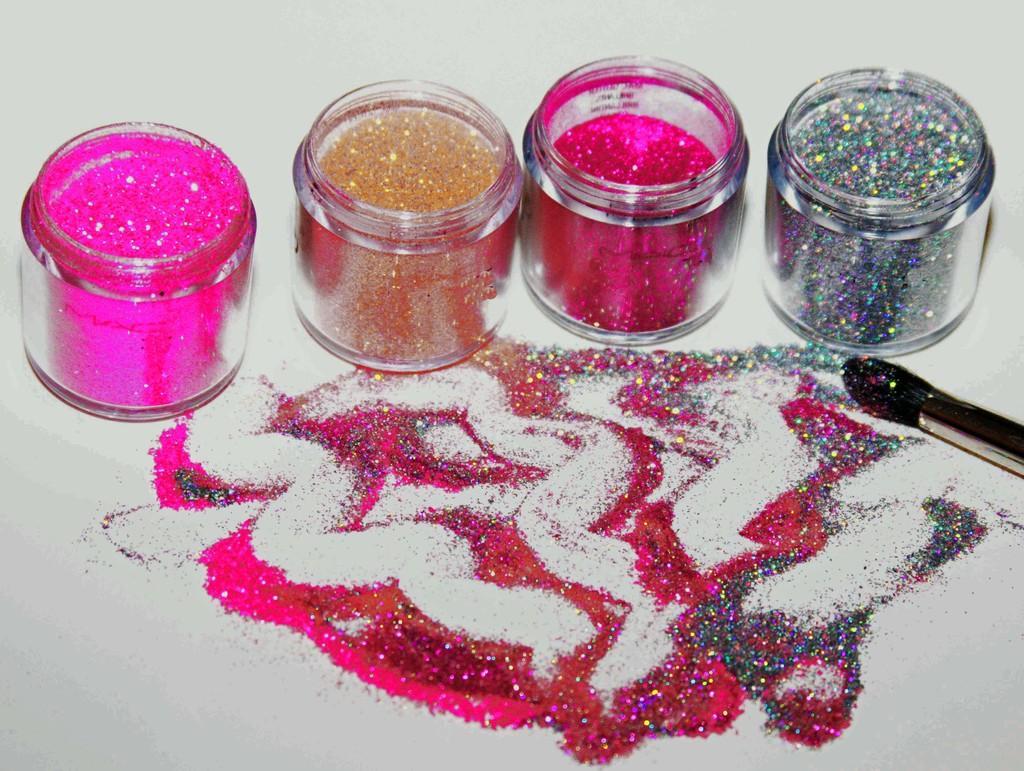Could you give a brief overview of what you see in this image? This is a zoomed in picture. In the foreground there is a white color object seems to be a table on the top of which we can see the powder of glitter and a brush and we can see the four boxes containing different colors of glitters are placed. 